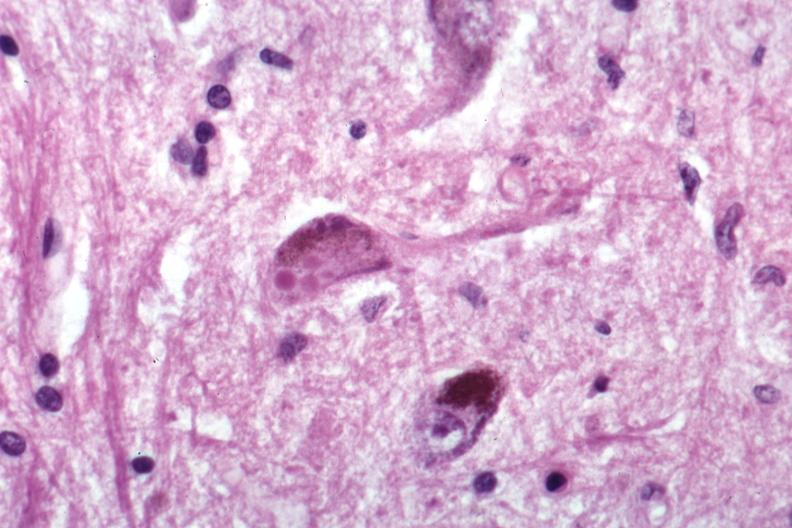what is present?
Answer the question using a single word or phrase. Brain 